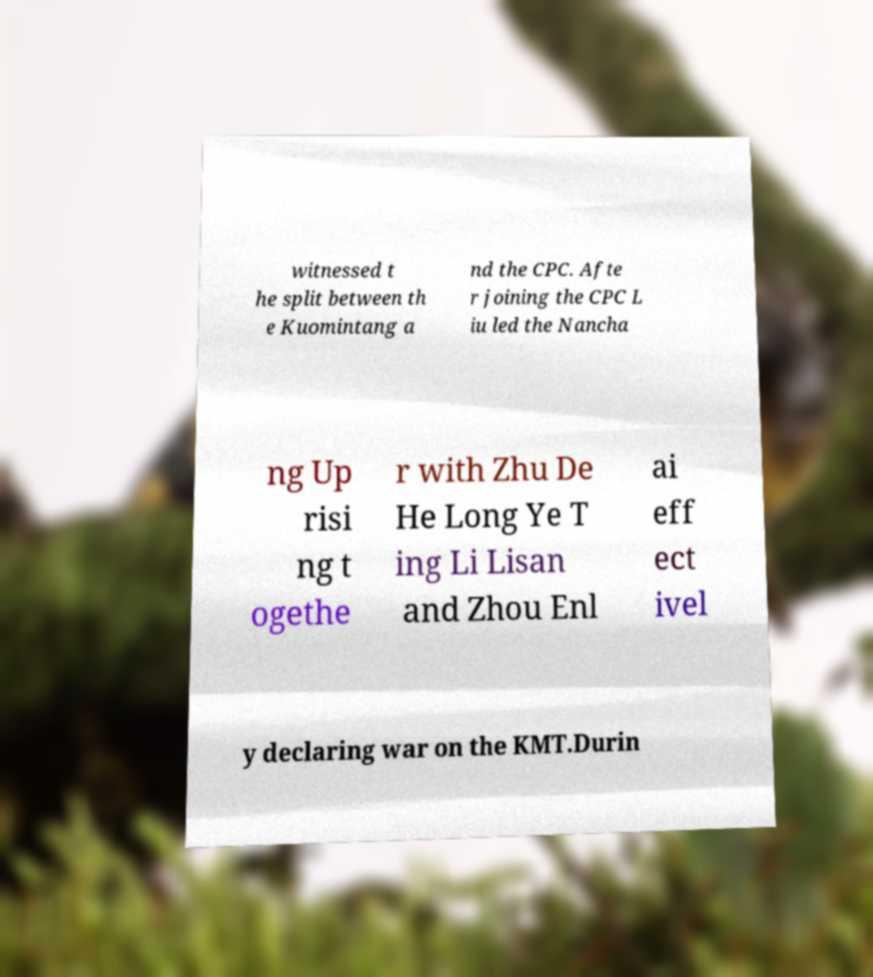What messages or text are displayed in this image? I need them in a readable, typed format. witnessed t he split between th e Kuomintang a nd the CPC. Afte r joining the CPC L iu led the Nancha ng Up risi ng t ogethe r with Zhu De He Long Ye T ing Li Lisan and Zhou Enl ai eff ect ivel y declaring war on the KMT.Durin 